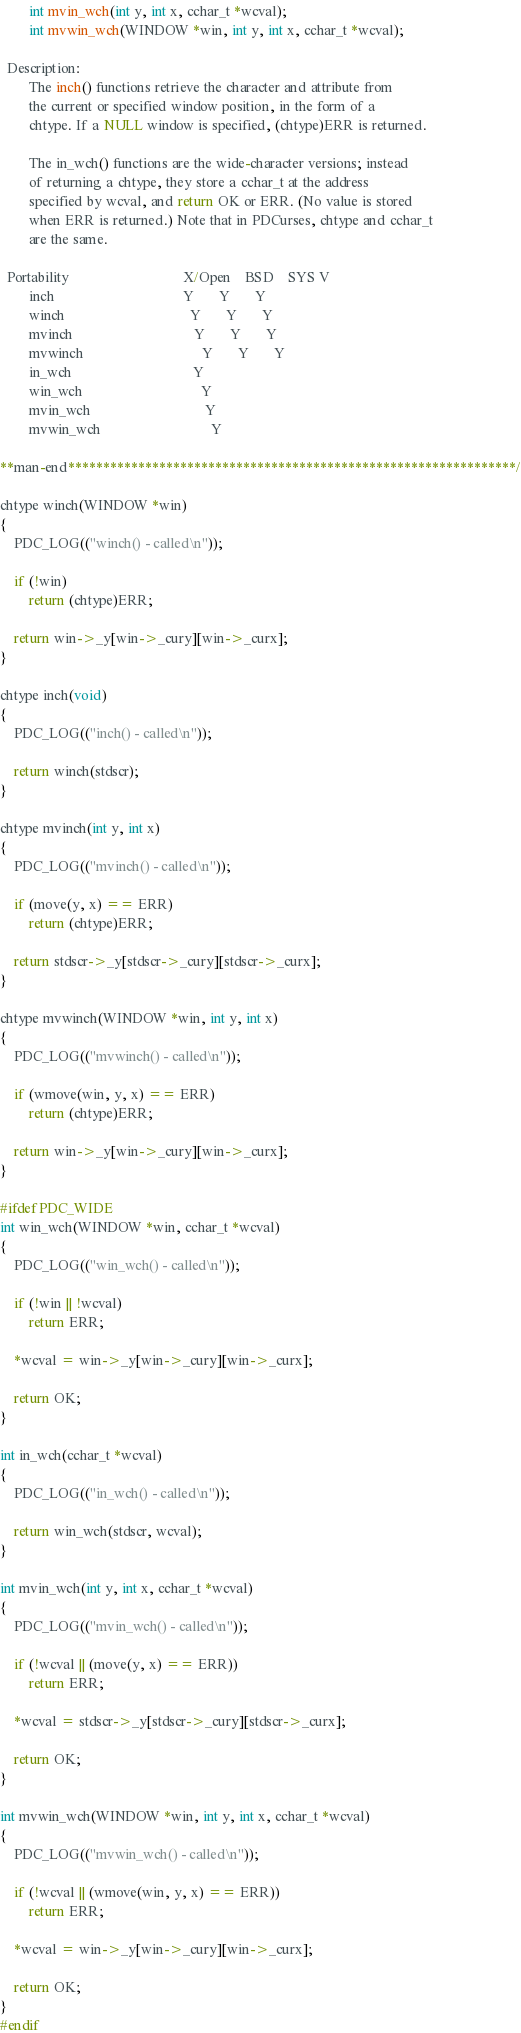<code> <loc_0><loc_0><loc_500><loc_500><_C_>        int mvin_wch(int y, int x, cchar_t *wcval);
        int mvwin_wch(WINDOW *win, int y, int x, cchar_t *wcval);

  Description:
        The inch() functions retrieve the character and attribute from 
        the current or specified window position, in the form of a 
        chtype. If a NULL window is specified, (chtype)ERR is returned.

        The in_wch() functions are the wide-character versions; instead 
        of returning a chtype, they store a cchar_t at the address 
        specified by wcval, and return OK or ERR. (No value is stored 
        when ERR is returned.) Note that in PDCurses, chtype and cchar_t 
        are the same.

  Portability                                X/Open    BSD    SYS V
        inch                                    Y       Y       Y
        winch                                   Y       Y       Y
        mvinch                                  Y       Y       Y
        mvwinch                                 Y       Y       Y
        in_wch                                  Y
        win_wch                                 Y
        mvin_wch                                Y
        mvwin_wch                               Y

**man-end****************************************************************/

chtype winch(WINDOW *win)
{
    PDC_LOG(("winch() - called\n"));

    if (!win)
        return (chtype)ERR;

    return win->_y[win->_cury][win->_curx];
}

chtype inch(void)
{
    PDC_LOG(("inch() - called\n"));

    return winch(stdscr);
}

chtype mvinch(int y, int x)
{
    PDC_LOG(("mvinch() - called\n"));

    if (move(y, x) == ERR)
        return (chtype)ERR;

    return stdscr->_y[stdscr->_cury][stdscr->_curx];
}

chtype mvwinch(WINDOW *win, int y, int x)
{
    PDC_LOG(("mvwinch() - called\n"));

    if (wmove(win, y, x) == ERR)
        return (chtype)ERR;

    return win->_y[win->_cury][win->_curx];
}

#ifdef PDC_WIDE
int win_wch(WINDOW *win, cchar_t *wcval)
{
    PDC_LOG(("win_wch() - called\n"));

    if (!win || !wcval)
        return ERR;

    *wcval = win->_y[win->_cury][win->_curx];

    return OK;
}

int in_wch(cchar_t *wcval)
{
    PDC_LOG(("in_wch() - called\n"));

    return win_wch(stdscr, wcval);
}

int mvin_wch(int y, int x, cchar_t *wcval)
{
    PDC_LOG(("mvin_wch() - called\n"));

    if (!wcval || (move(y, x) == ERR))
        return ERR;

    *wcval = stdscr->_y[stdscr->_cury][stdscr->_curx];

    return OK;
}

int mvwin_wch(WINDOW *win, int y, int x, cchar_t *wcval)
{
    PDC_LOG(("mvwin_wch() - called\n"));

    if (!wcval || (wmove(win, y, x) == ERR))
        return ERR;

    *wcval = win->_y[win->_cury][win->_curx];

    return OK;
}
#endif
</code> 